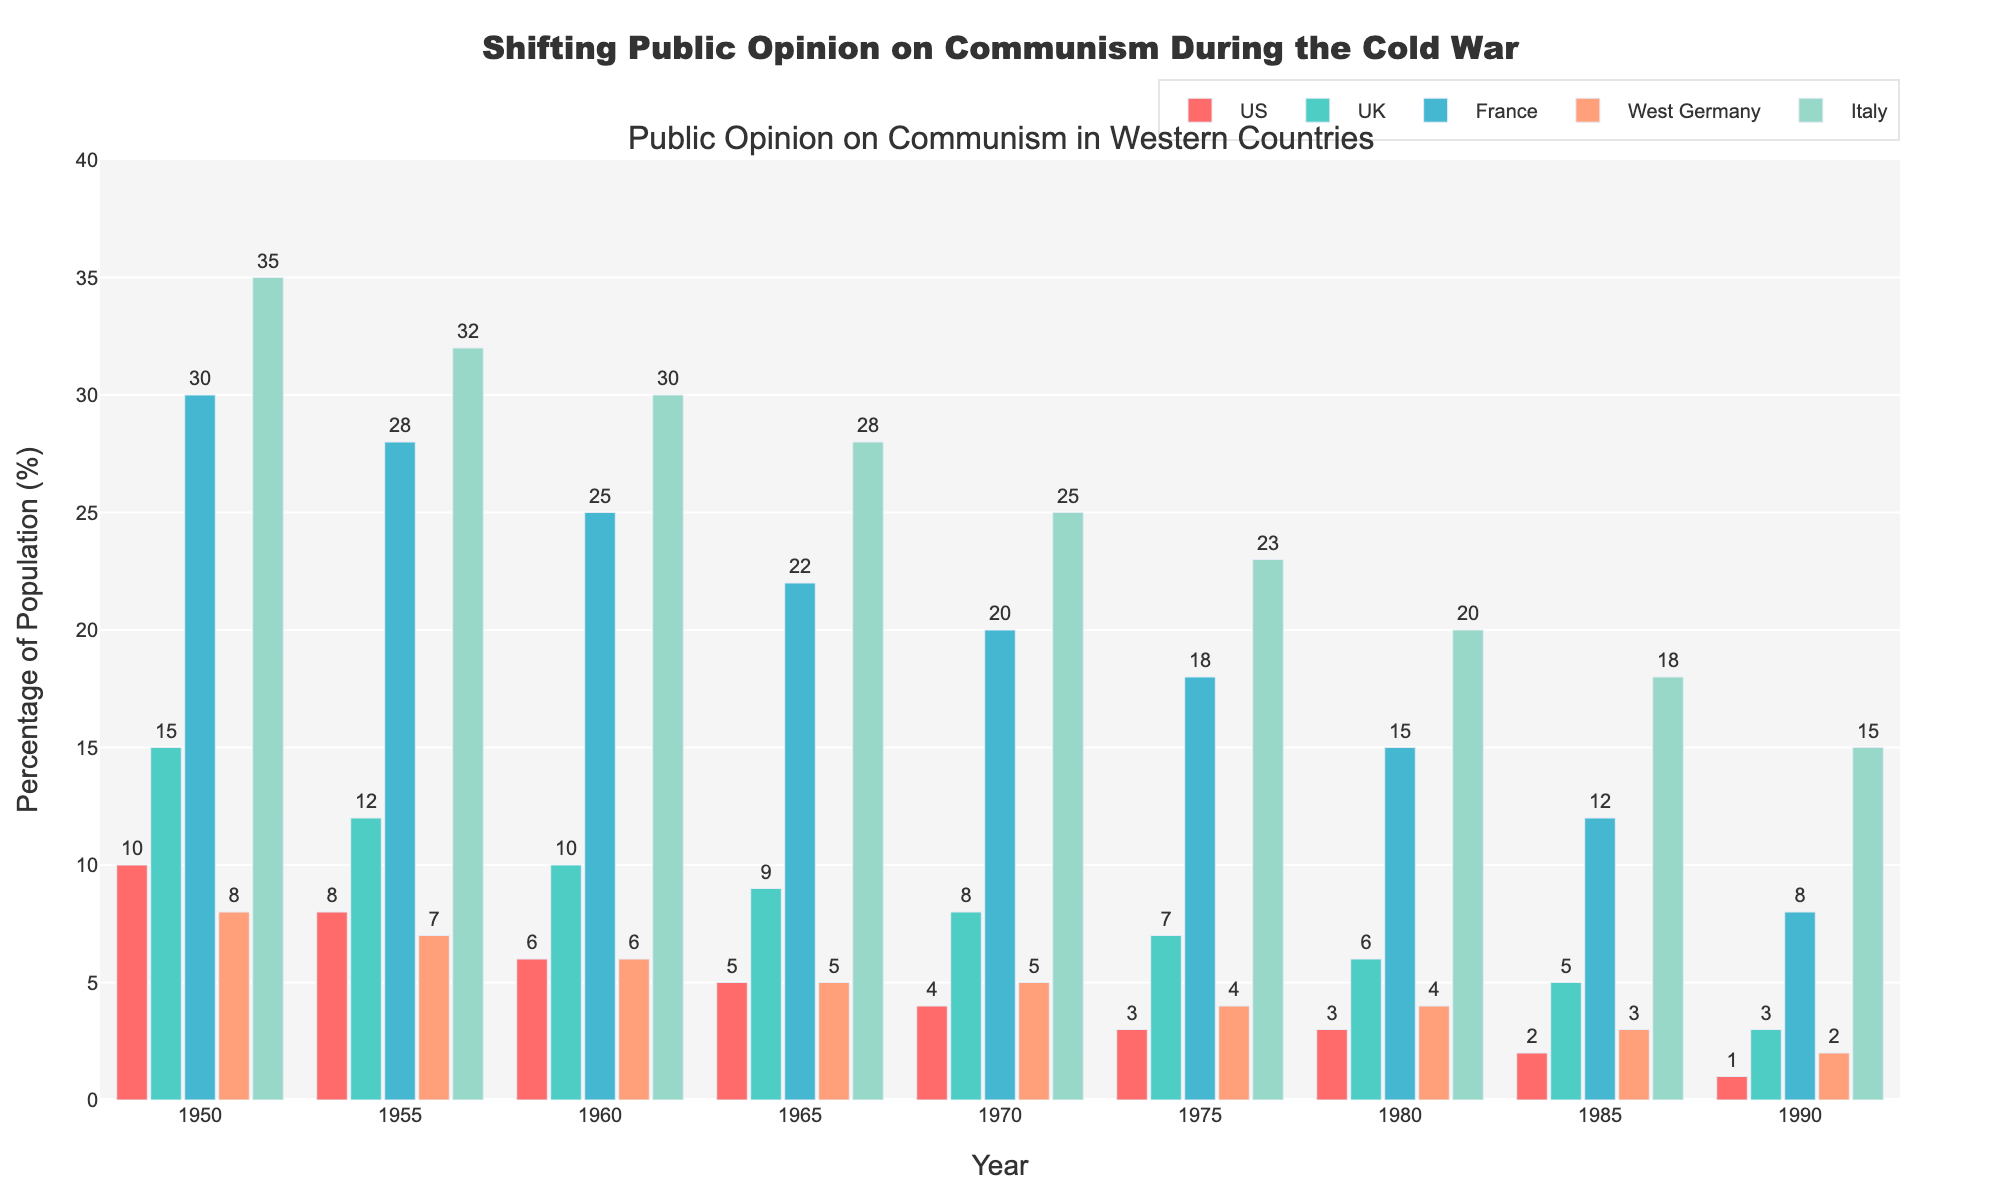What's the overall trend of public opinion on communism in Western countries from 1950 to 1990? The percentages in all five countries (US, UK, France, West Germany, and Italy) decrease significantly over the decades. For example, in the US, the percentage drops from 10% in 1950 to 1% in 1990. This pattern is consistent across all countries, indicating a declining trend in public support for communism.
Answer: Declining Which country had the highest percentage of public opinion favoring communism in 1950? By examining the heights of the bars, Italy, with a percentage of 35%, had the highest public opinion favoring communism in 1950.
Answer: Italy How much did public opinion on communism drop in France from 1950 to 1990? In 1950, France had 30% of the population favoring communism, and this dropped to 8% in 1990. The difference is calculated as 30% - 8%, resulting in a 22% drop.
Answer: 22% In 1975, did the US or West Germany have a lower public opinion on communism, and by how much? In 1975, the US had 3% while West Germany had 4%. The US had a lower public opinion by 1%.
Answer: US by 1% Which year showed the greatest difference in public opinion on communism between the UK and Italy? In 1950, the UK had 15% and Italy had 35%, making the difference 20%. By comparing this to other years, 1950 shows the greatest difference.
Answer: 1950 What is the average percentage of public opinion on communism in West Germany between 1950 and 1990? To find the average, sum the percentages for West Germany across all years: (8 + 7 + 6 + 5 + 5 + 4 + 4 + 3 + 2) = 44. Divide this by the number of years (9): 44 / 9 ≈ 4.89%.
Answer: 4.89% Which country shows the least variation in public opinion on communism over the decades? The bars for West Germany appear consistent and close across the years. Calculating the range (maximum - minimum), we see West Germany's percentages vary from 8% to 2%, a range of 6%, which is the smallest difference compared to other countries.
Answer: West Germany Between 1965 and 1985, which country had the largest decrease in public opinion on communism? For each country, calculate the difference between the values in 1965 and 1985: US (5 - 2 = 3), UK (9 - 5 = 4), France (22 - 12 = 10), West Germany (5 - 3 = 2), Italy (28 - 18 = 10). France and Italy both had a decrease of 10%, the largest among the countries.
Answer: France and Italy Looking at the bar colors, which color represents France and how does it help in distinguishing the data? France is represented by a blue color. The color coding helps in distinguishing France's data quickly from other countries when analyzing trends and making comparisons.
Answer: Blue 